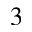<formula> <loc_0><loc_0><loc_500><loc_500>^ { 3 }</formula> 